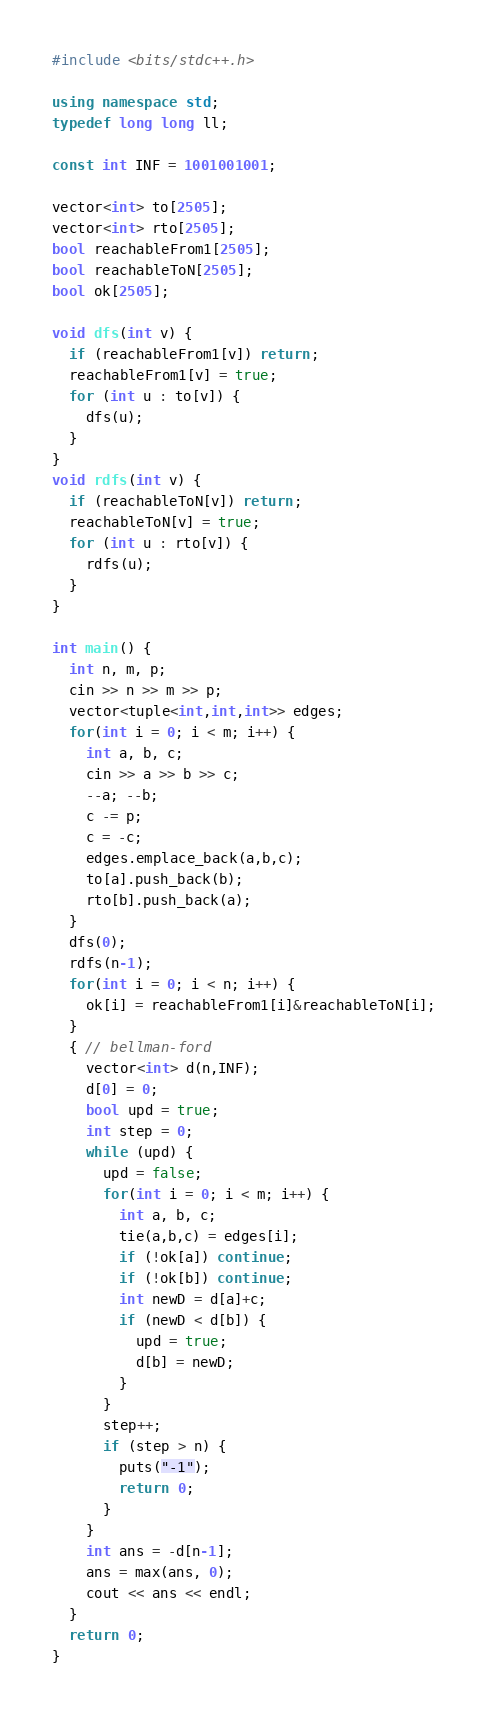<code> <loc_0><loc_0><loc_500><loc_500><_C++_>#include <bits/stdc++.h>

using namespace std;
typedef long long ll;

const int INF = 1001001001;

vector<int> to[2505];
vector<int> rto[2505];
bool reachableFrom1[2505];
bool reachableToN[2505];
bool ok[2505];

void dfs(int v) {
  if (reachableFrom1[v]) return;
  reachableFrom1[v] = true;
  for (int u : to[v]) {
    dfs(u);
  }
}
void rdfs(int v) {
  if (reachableToN[v]) return;
  reachableToN[v] = true;
  for (int u : rto[v]) {
    rdfs(u);
  }
}

int main() {
  int n, m, p;
  cin >> n >> m >> p;
  vector<tuple<int,int,int>> edges;
  for(int i = 0; i < m; i++) {
    int a, b, c;
    cin >> a >> b >> c;
    --a; --b;
    c -= p;
    c = -c;
    edges.emplace_back(a,b,c);
    to[a].push_back(b);
    rto[b].push_back(a);
  }
  dfs(0);
  rdfs(n-1);
  for(int i = 0; i < n; i++) {
    ok[i] = reachableFrom1[i]&reachableToN[i];
  }
  { // bellman-ford
    vector<int> d(n,INF);
    d[0] = 0;
    bool upd = true;
    int step = 0;
    while (upd) {
      upd = false;
      for(int i = 0; i < m; i++) {
        int a, b, c;
        tie(a,b,c) = edges[i];
        if (!ok[a]) continue;
        if (!ok[b]) continue;
        int newD = d[a]+c;
        if (newD < d[b]) {
          upd = true;
          d[b] = newD;
        }
      }
      step++;
      if (step > n) {
        puts("-1");
        return 0;
      }
    }
    int ans = -d[n-1];
    ans = max(ans, 0);
    cout << ans << endl;
  }
  return 0;
}
</code> 